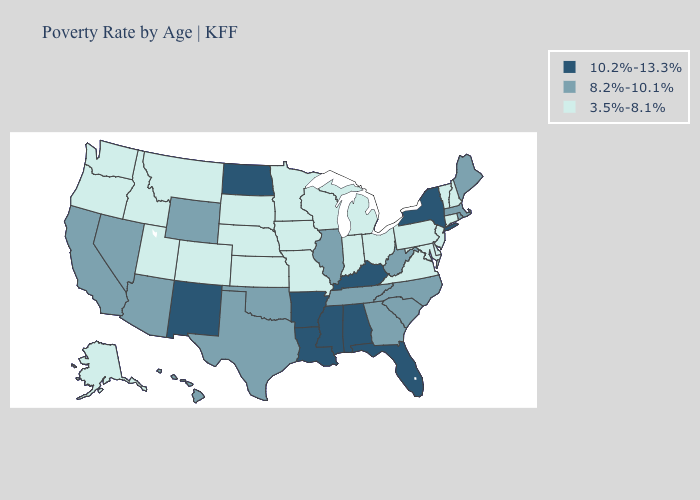Which states have the lowest value in the USA?
Answer briefly. Alaska, Colorado, Connecticut, Delaware, Idaho, Indiana, Iowa, Kansas, Maryland, Michigan, Minnesota, Missouri, Montana, Nebraska, New Hampshire, New Jersey, Ohio, Oregon, Pennsylvania, South Dakota, Utah, Vermont, Virginia, Washington, Wisconsin. Does Mississippi have the lowest value in the South?
Write a very short answer. No. Name the states that have a value in the range 8.2%-10.1%?
Write a very short answer. Arizona, California, Georgia, Hawaii, Illinois, Maine, Massachusetts, Nevada, North Carolina, Oklahoma, Rhode Island, South Carolina, Tennessee, Texas, West Virginia, Wyoming. Does Washington have a higher value than Hawaii?
Answer briefly. No. What is the value of Pennsylvania?
Be succinct. 3.5%-8.1%. Does Tennessee have the highest value in the USA?
Be succinct. No. Does the first symbol in the legend represent the smallest category?
Answer briefly. No. Does California have a higher value than Utah?
Write a very short answer. Yes. Name the states that have a value in the range 8.2%-10.1%?
Give a very brief answer. Arizona, California, Georgia, Hawaii, Illinois, Maine, Massachusetts, Nevada, North Carolina, Oklahoma, Rhode Island, South Carolina, Tennessee, Texas, West Virginia, Wyoming. Among the states that border Massachusetts , does New York have the lowest value?
Keep it brief. No. Name the states that have a value in the range 10.2%-13.3%?
Be succinct. Alabama, Arkansas, Florida, Kentucky, Louisiana, Mississippi, New Mexico, New York, North Dakota. What is the value of Wisconsin?
Keep it brief. 3.5%-8.1%. Does Virginia have the lowest value in the South?
Answer briefly. Yes. What is the value of Pennsylvania?
Concise answer only. 3.5%-8.1%. Does the map have missing data?
Give a very brief answer. No. 